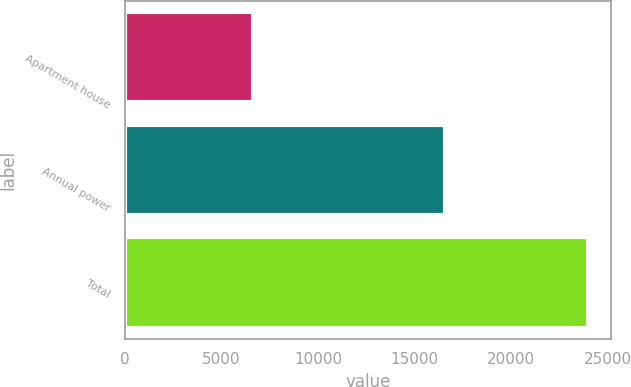<chart> <loc_0><loc_0><loc_500><loc_500><bar_chart><fcel>Apartment house<fcel>Annual power<fcel>Total<nl><fcel>6614<fcel>16577<fcel>23976<nl></chart> 